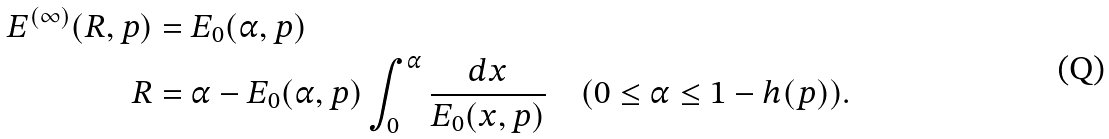<formula> <loc_0><loc_0><loc_500><loc_500>E ^ { ( \infty ) } ( R , p ) & = E _ { 0 } ( \alpha , p ) \\ R & = \alpha - E _ { 0 } ( \alpha , p ) \int _ { 0 } ^ { \alpha } \frac { d x } { E _ { 0 } ( x , p ) } \quad ( 0 \leq \alpha \leq 1 - h ( p ) ) .</formula> 